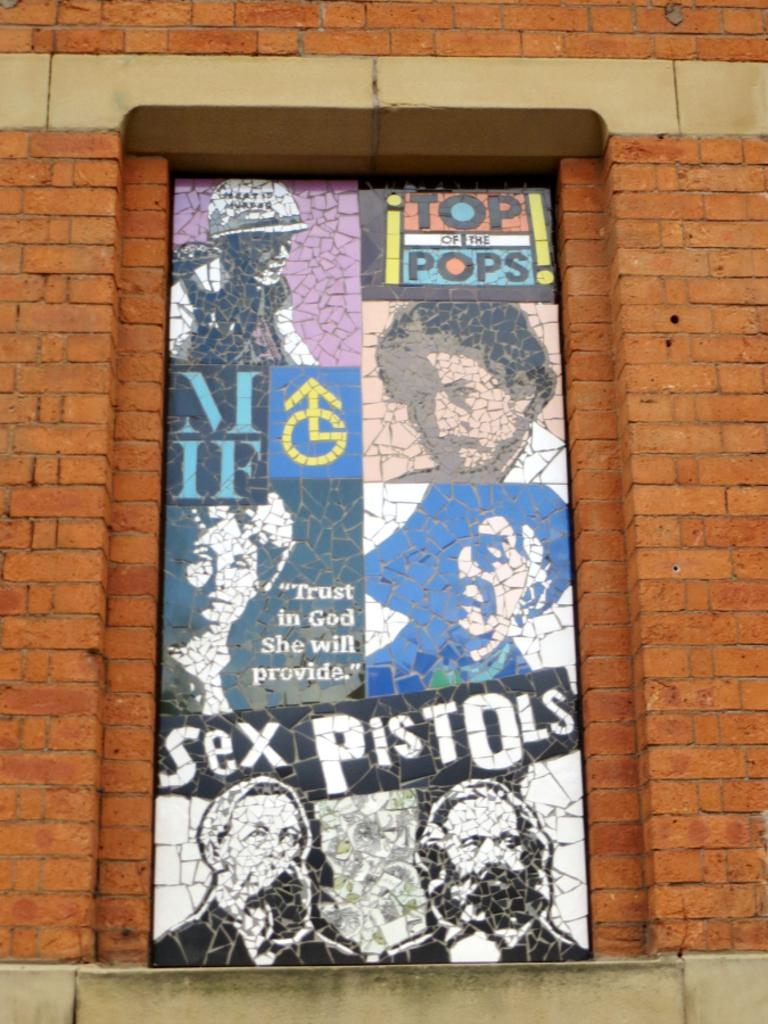<image>
Render a clear and concise summary of the photo. An ad on a brick wall that says Top of the Pops and features the Sex Pistols. 